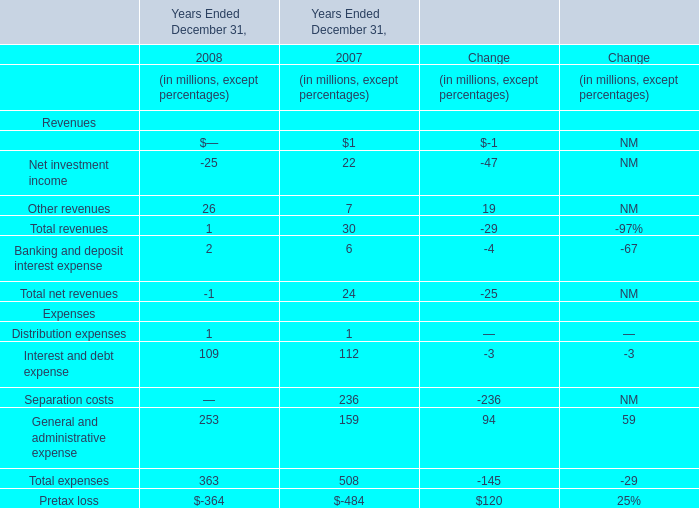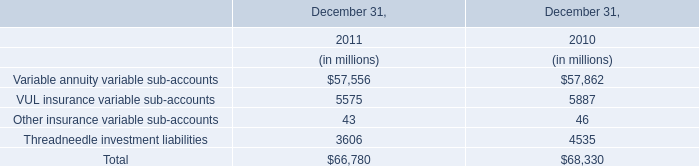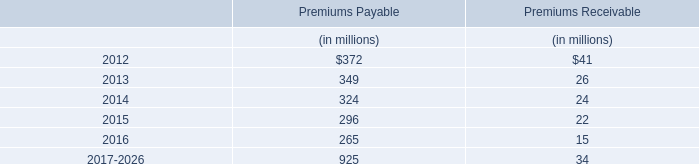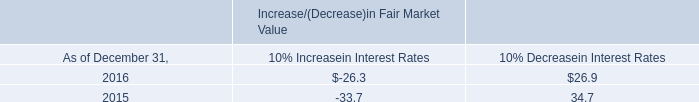what is the percentage change in interest income from 2015 to 2016? 
Computations: ((20.1 - 22.8) / 22.8)
Answer: -0.11842. 